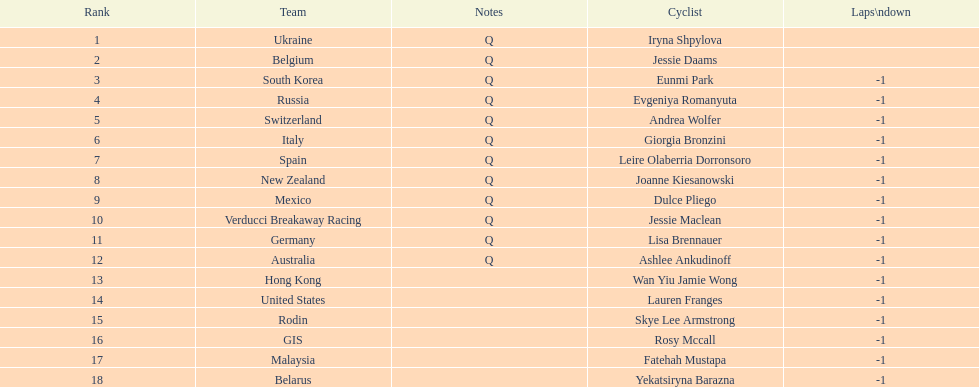How many cyclist are not listed with a country team? 3. 